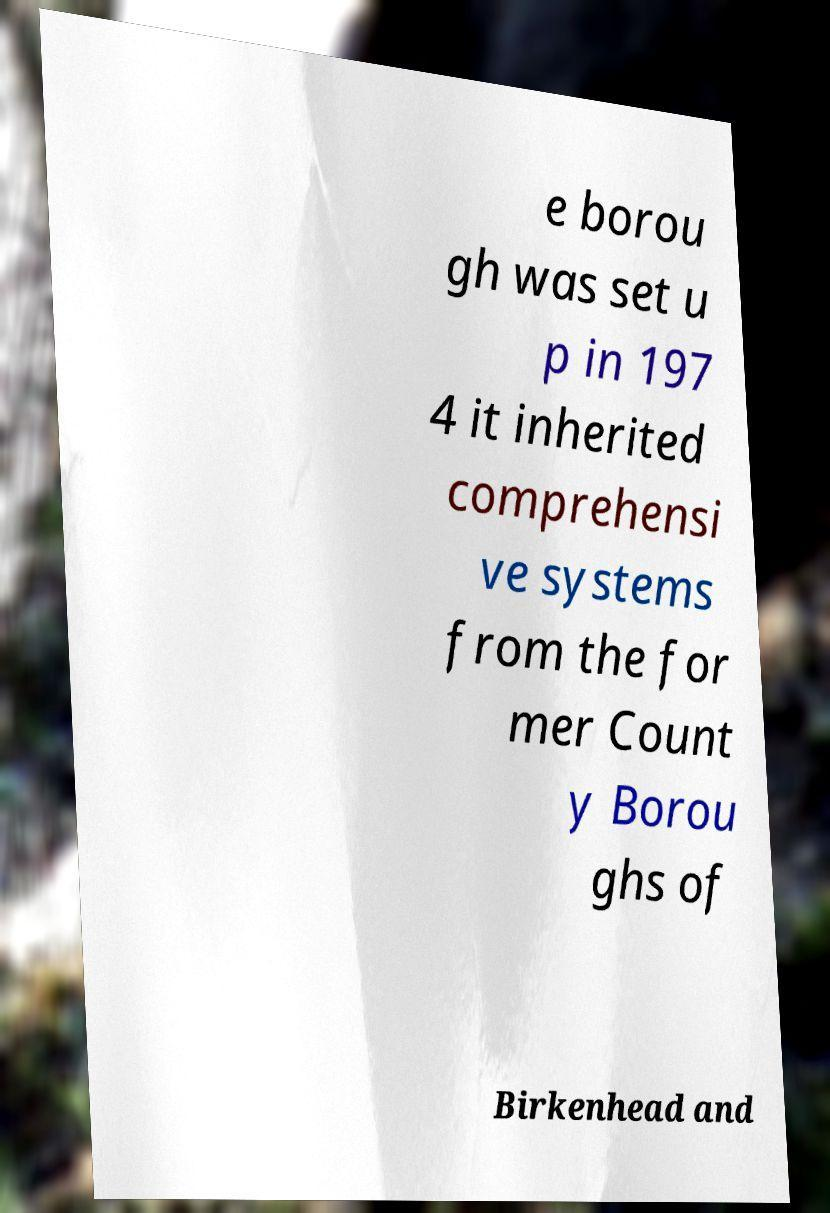Please read and relay the text visible in this image. What does it say? e borou gh was set u p in 197 4 it inherited comprehensi ve systems from the for mer Count y Borou ghs of Birkenhead and 